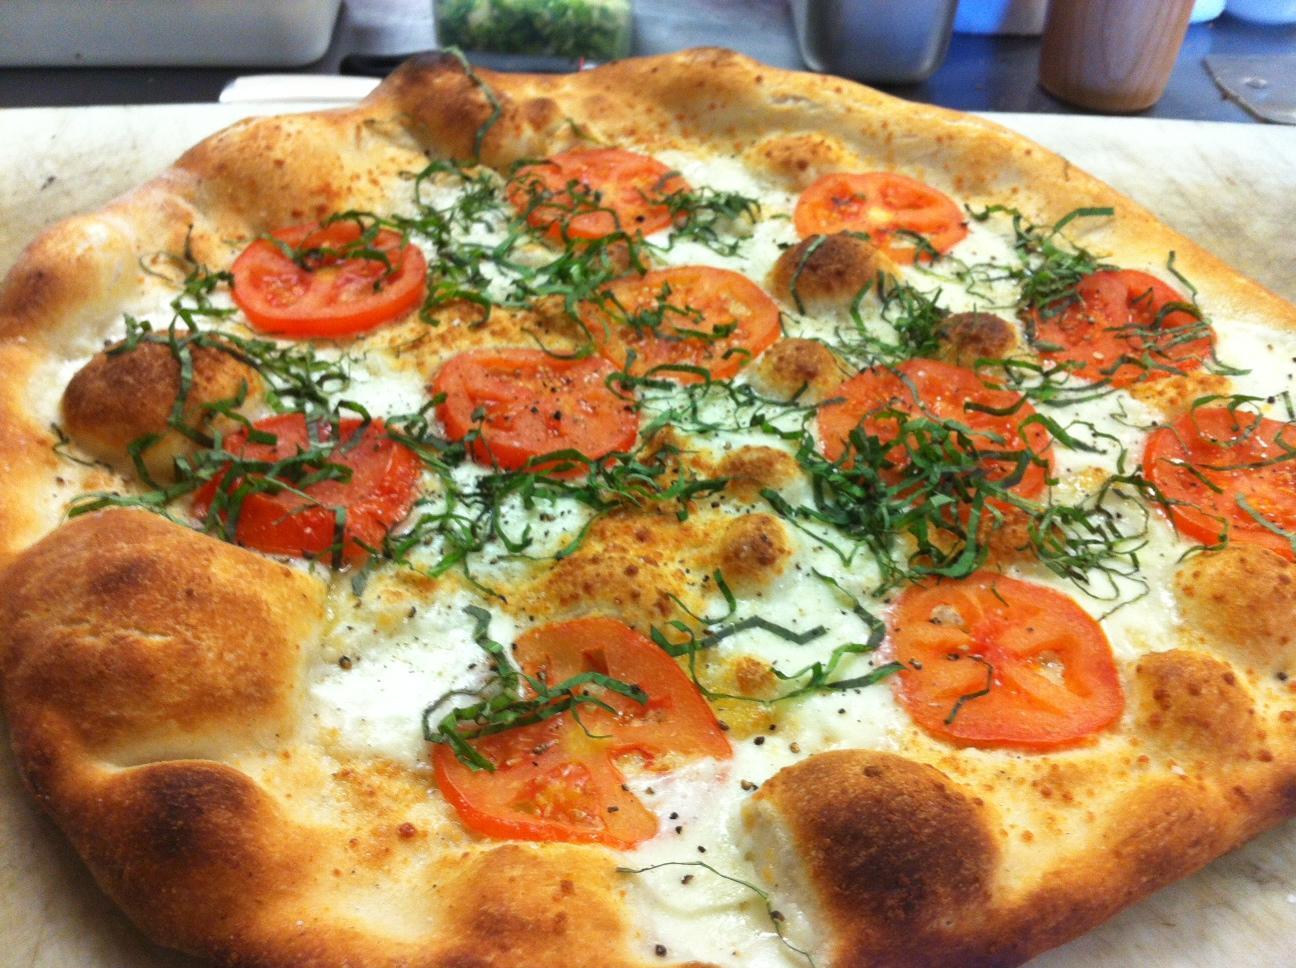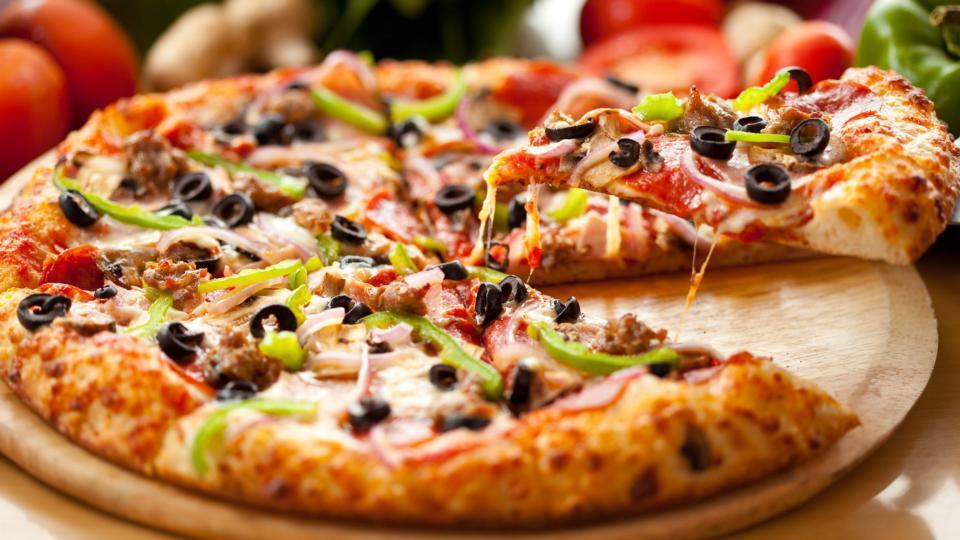The first image is the image on the left, the second image is the image on the right. Considering the images on both sides, is "The pizza in one of the images is placed on a metal baking pan." valid? Answer yes or no. No. 